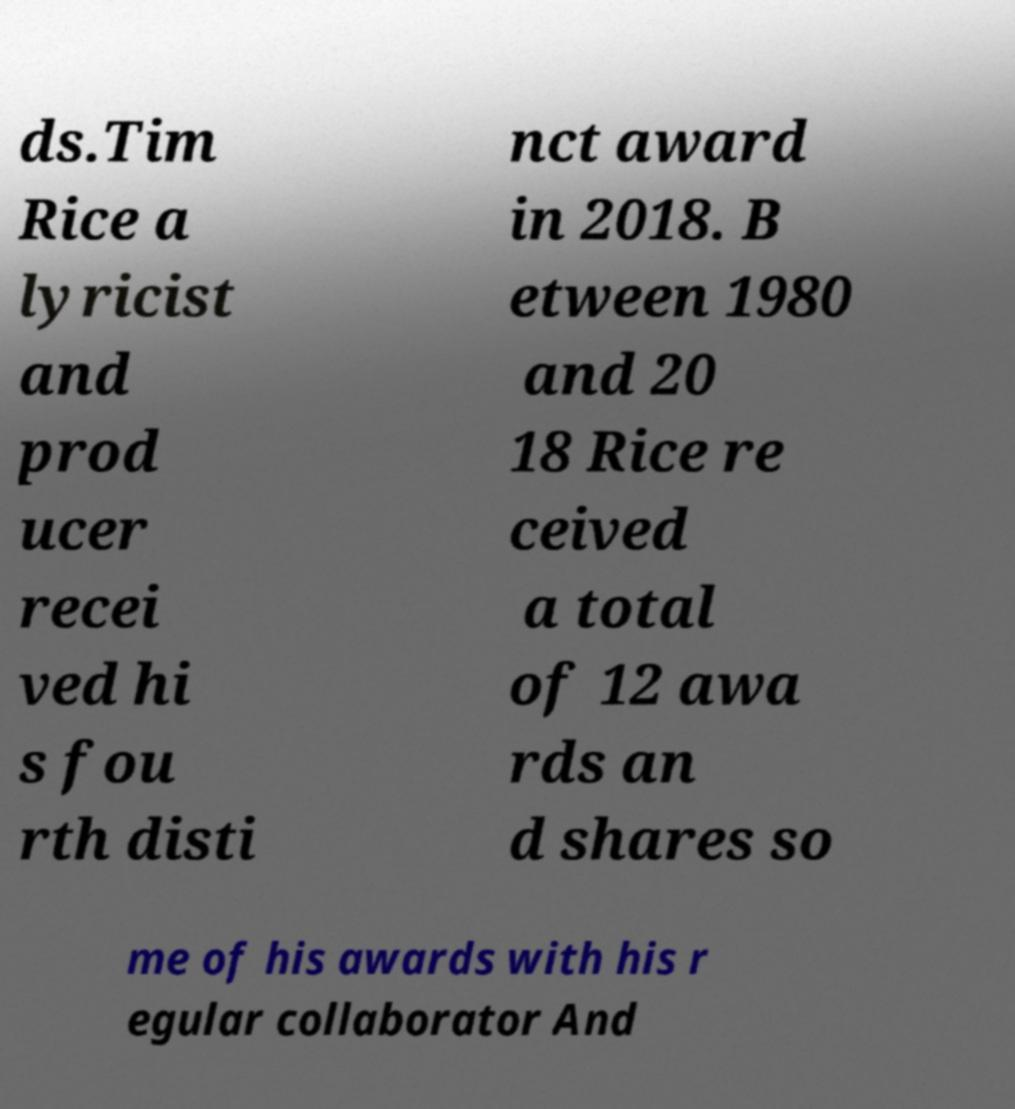Could you extract and type out the text from this image? ds.Tim Rice a lyricist and prod ucer recei ved hi s fou rth disti nct award in 2018. B etween 1980 and 20 18 Rice re ceived a total of 12 awa rds an d shares so me of his awards with his r egular collaborator And 